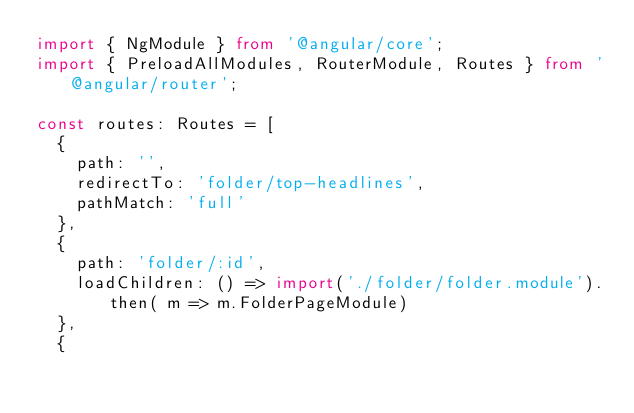Convert code to text. <code><loc_0><loc_0><loc_500><loc_500><_TypeScript_>import { NgModule } from '@angular/core';
import { PreloadAllModules, RouterModule, Routes } from '@angular/router';

const routes: Routes = [
  {
    path: '',
    redirectTo: 'folder/top-headlines',
    pathMatch: 'full'
  },
  {
    path: 'folder/:id',
    loadChildren: () => import('./folder/folder.module').then( m => m.FolderPageModule)
  },
  {</code> 